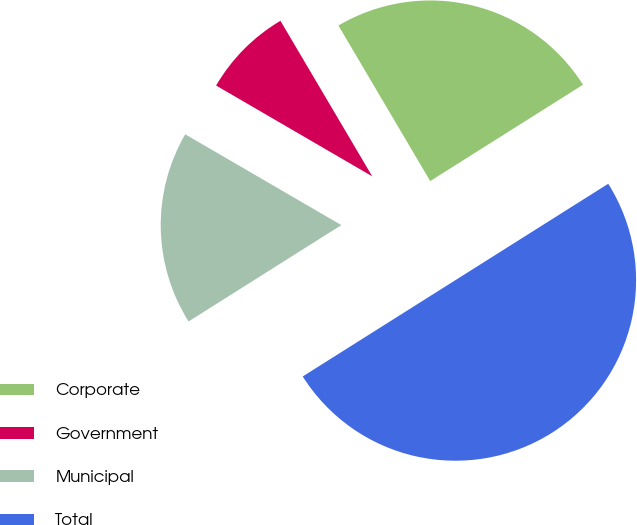<chart> <loc_0><loc_0><loc_500><loc_500><pie_chart><fcel>Corporate<fcel>Government<fcel>Municipal<fcel>Total<nl><fcel>24.53%<fcel>8.13%<fcel>17.34%<fcel>50.0%<nl></chart> 